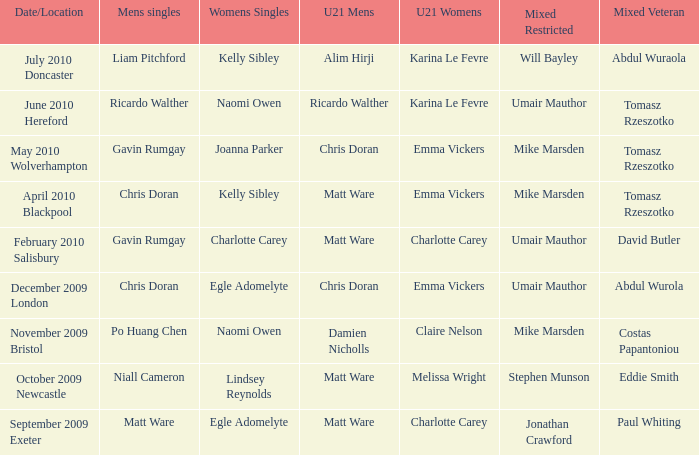Who emerged victorious in the mixed restricted when matt ware claimed the men's singles title? Jonathan Crawford. 